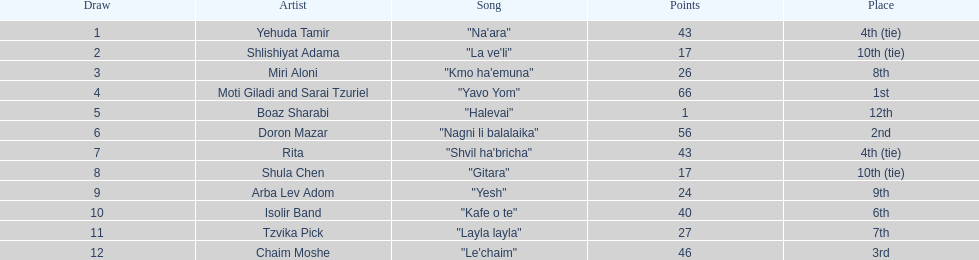Did the song "gitara" or "yesh" earn more points? "Yesh". 